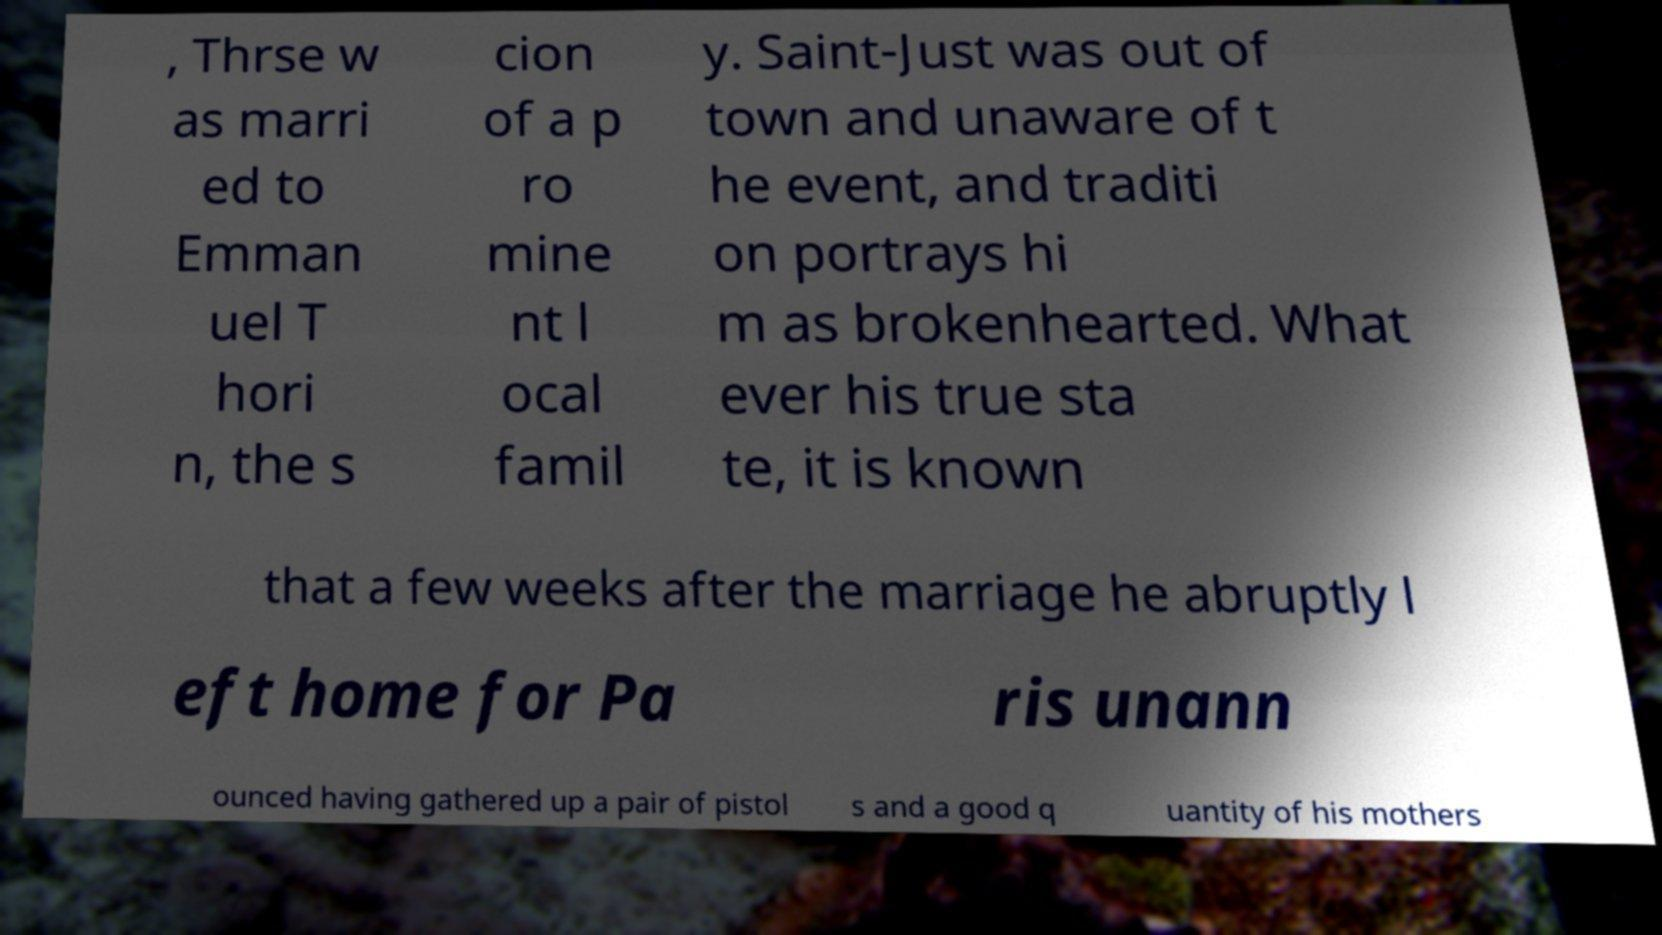Please identify and transcribe the text found in this image. , Thrse w as marri ed to Emman uel T hori n, the s cion of a p ro mine nt l ocal famil y. Saint-Just was out of town and unaware of t he event, and traditi on portrays hi m as brokenhearted. What ever his true sta te, it is known that a few weeks after the marriage he abruptly l eft home for Pa ris unann ounced having gathered up a pair of pistol s and a good q uantity of his mothers 